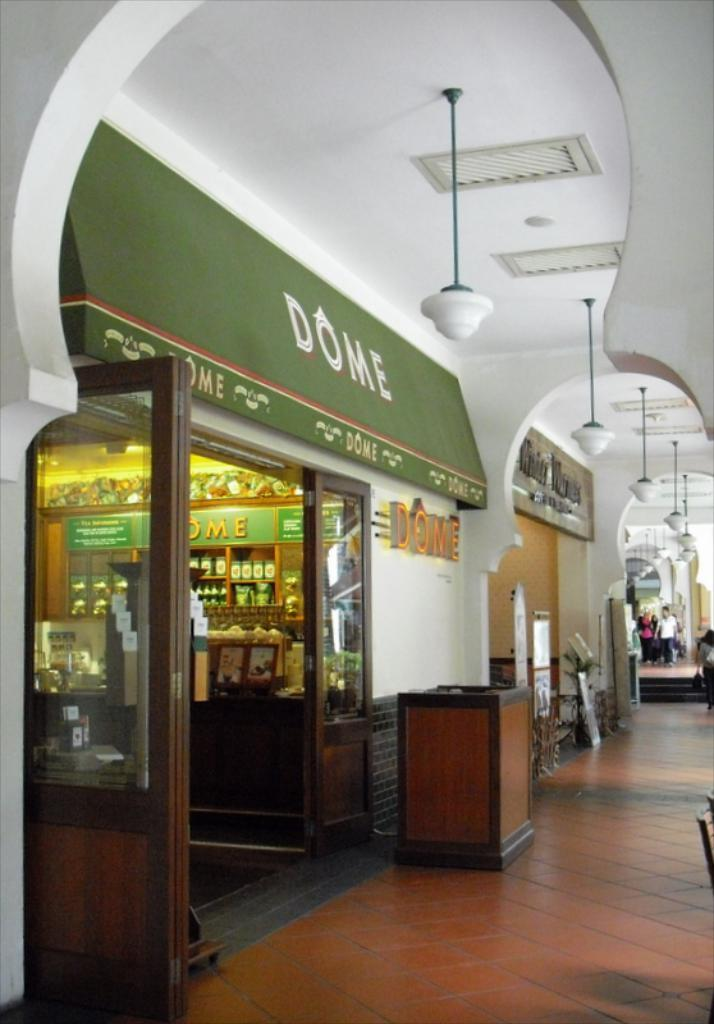<image>
Give a short and clear explanation of the subsequent image. A store or restaurant with Dome on the awning outside it. 